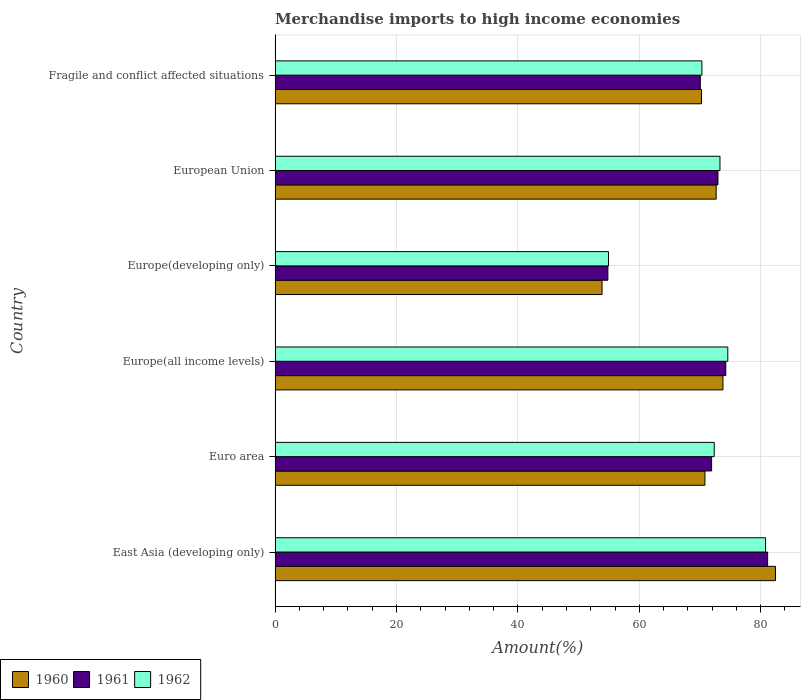Are the number of bars per tick equal to the number of legend labels?
Offer a terse response. Yes. Are the number of bars on each tick of the Y-axis equal?
Provide a succinct answer. Yes. How many bars are there on the 4th tick from the top?
Give a very brief answer. 3. How many bars are there on the 3rd tick from the bottom?
Ensure brevity in your answer.  3. What is the label of the 4th group of bars from the top?
Provide a succinct answer. Europe(all income levels). What is the percentage of amount earned from merchandise imports in 1960 in Fragile and conflict affected situations?
Your answer should be very brief. 70.25. Across all countries, what is the maximum percentage of amount earned from merchandise imports in 1962?
Provide a succinct answer. 80.8. Across all countries, what is the minimum percentage of amount earned from merchandise imports in 1962?
Make the answer very short. 54.93. In which country was the percentage of amount earned from merchandise imports in 1962 maximum?
Your response must be concise. East Asia (developing only). In which country was the percentage of amount earned from merchandise imports in 1962 minimum?
Your answer should be very brief. Europe(developing only). What is the total percentage of amount earned from merchandise imports in 1961 in the graph?
Your answer should be compact. 425.14. What is the difference between the percentage of amount earned from merchandise imports in 1961 in European Union and that in Fragile and conflict affected situations?
Offer a very short reply. 2.91. What is the difference between the percentage of amount earned from merchandise imports in 1960 in European Union and the percentage of amount earned from merchandise imports in 1962 in Fragile and conflict affected situations?
Your answer should be very brief. 2.35. What is the average percentage of amount earned from merchandise imports in 1961 per country?
Provide a succinct answer. 70.86. What is the difference between the percentage of amount earned from merchandise imports in 1960 and percentage of amount earned from merchandise imports in 1961 in Euro area?
Keep it short and to the point. -1.1. What is the ratio of the percentage of amount earned from merchandise imports in 1962 in East Asia (developing only) to that in Europe(developing only)?
Ensure brevity in your answer.  1.47. Is the difference between the percentage of amount earned from merchandise imports in 1960 in East Asia (developing only) and Europe(developing only) greater than the difference between the percentage of amount earned from merchandise imports in 1961 in East Asia (developing only) and Europe(developing only)?
Ensure brevity in your answer.  Yes. What is the difference between the highest and the second highest percentage of amount earned from merchandise imports in 1961?
Your answer should be very brief. 6.89. What is the difference between the highest and the lowest percentage of amount earned from merchandise imports in 1962?
Give a very brief answer. 25.88. In how many countries, is the percentage of amount earned from merchandise imports in 1960 greater than the average percentage of amount earned from merchandise imports in 1960 taken over all countries?
Provide a short and direct response. 4. What does the 2nd bar from the top in East Asia (developing only) represents?
Offer a very short reply. 1961. Is it the case that in every country, the sum of the percentage of amount earned from merchandise imports in 1961 and percentage of amount earned from merchandise imports in 1960 is greater than the percentage of amount earned from merchandise imports in 1962?
Make the answer very short. Yes. How many bars are there?
Ensure brevity in your answer.  18. Are all the bars in the graph horizontal?
Ensure brevity in your answer.  Yes. How many countries are there in the graph?
Your answer should be very brief. 6. What is the difference between two consecutive major ticks on the X-axis?
Your answer should be compact. 20. Does the graph contain any zero values?
Keep it short and to the point. No. Does the graph contain grids?
Your response must be concise. Yes. What is the title of the graph?
Give a very brief answer. Merchandise imports to high income economies. What is the label or title of the X-axis?
Your answer should be very brief. Amount(%). What is the label or title of the Y-axis?
Give a very brief answer. Country. What is the Amount(%) of 1960 in East Asia (developing only)?
Provide a succinct answer. 82.44. What is the Amount(%) in 1961 in East Asia (developing only)?
Make the answer very short. 81.14. What is the Amount(%) in 1962 in East Asia (developing only)?
Offer a terse response. 80.8. What is the Amount(%) of 1960 in Euro area?
Provide a short and direct response. 70.81. What is the Amount(%) of 1961 in Euro area?
Keep it short and to the point. 71.91. What is the Amount(%) in 1962 in Euro area?
Offer a very short reply. 72.34. What is the Amount(%) in 1960 in Europe(all income levels)?
Offer a terse response. 73.78. What is the Amount(%) of 1961 in Europe(all income levels)?
Give a very brief answer. 74.25. What is the Amount(%) in 1962 in Europe(all income levels)?
Provide a succinct answer. 74.58. What is the Amount(%) in 1960 in Europe(developing only)?
Ensure brevity in your answer.  53.86. What is the Amount(%) in 1961 in Europe(developing only)?
Ensure brevity in your answer.  54.82. What is the Amount(%) of 1962 in Europe(developing only)?
Provide a succinct answer. 54.93. What is the Amount(%) in 1960 in European Union?
Your response must be concise. 72.67. What is the Amount(%) in 1961 in European Union?
Your response must be concise. 72.96. What is the Amount(%) of 1962 in European Union?
Your answer should be compact. 73.29. What is the Amount(%) of 1960 in Fragile and conflict affected situations?
Offer a terse response. 70.25. What is the Amount(%) of 1961 in Fragile and conflict affected situations?
Your answer should be compact. 70.05. What is the Amount(%) in 1962 in Fragile and conflict affected situations?
Your answer should be very brief. 70.31. Across all countries, what is the maximum Amount(%) of 1960?
Provide a short and direct response. 82.44. Across all countries, what is the maximum Amount(%) of 1961?
Your response must be concise. 81.14. Across all countries, what is the maximum Amount(%) in 1962?
Your answer should be very brief. 80.8. Across all countries, what is the minimum Amount(%) of 1960?
Make the answer very short. 53.86. Across all countries, what is the minimum Amount(%) of 1961?
Offer a very short reply. 54.82. Across all countries, what is the minimum Amount(%) of 1962?
Your response must be concise. 54.93. What is the total Amount(%) of 1960 in the graph?
Offer a terse response. 423.81. What is the total Amount(%) of 1961 in the graph?
Ensure brevity in your answer.  425.14. What is the total Amount(%) of 1962 in the graph?
Make the answer very short. 426.25. What is the difference between the Amount(%) of 1960 in East Asia (developing only) and that in Euro area?
Give a very brief answer. 11.62. What is the difference between the Amount(%) of 1961 in East Asia (developing only) and that in Euro area?
Provide a short and direct response. 9.23. What is the difference between the Amount(%) in 1962 in East Asia (developing only) and that in Euro area?
Your answer should be very brief. 8.46. What is the difference between the Amount(%) of 1960 in East Asia (developing only) and that in Europe(all income levels)?
Offer a terse response. 8.65. What is the difference between the Amount(%) of 1961 in East Asia (developing only) and that in Europe(all income levels)?
Your answer should be compact. 6.89. What is the difference between the Amount(%) in 1962 in East Asia (developing only) and that in Europe(all income levels)?
Your answer should be very brief. 6.22. What is the difference between the Amount(%) in 1960 in East Asia (developing only) and that in Europe(developing only)?
Ensure brevity in your answer.  28.57. What is the difference between the Amount(%) of 1961 in East Asia (developing only) and that in Europe(developing only)?
Make the answer very short. 26.32. What is the difference between the Amount(%) in 1962 in East Asia (developing only) and that in Europe(developing only)?
Provide a succinct answer. 25.88. What is the difference between the Amount(%) of 1960 in East Asia (developing only) and that in European Union?
Make the answer very short. 9.77. What is the difference between the Amount(%) in 1961 in East Asia (developing only) and that in European Union?
Offer a very short reply. 8.18. What is the difference between the Amount(%) of 1962 in East Asia (developing only) and that in European Union?
Give a very brief answer. 7.51. What is the difference between the Amount(%) of 1960 in East Asia (developing only) and that in Fragile and conflict affected situations?
Offer a very short reply. 12.19. What is the difference between the Amount(%) in 1961 in East Asia (developing only) and that in Fragile and conflict affected situations?
Offer a terse response. 11.09. What is the difference between the Amount(%) in 1962 in East Asia (developing only) and that in Fragile and conflict affected situations?
Your answer should be compact. 10.49. What is the difference between the Amount(%) of 1960 in Euro area and that in Europe(all income levels)?
Your answer should be very brief. -2.97. What is the difference between the Amount(%) in 1961 in Euro area and that in Europe(all income levels)?
Make the answer very short. -2.33. What is the difference between the Amount(%) in 1962 in Euro area and that in Europe(all income levels)?
Give a very brief answer. -2.24. What is the difference between the Amount(%) in 1960 in Euro area and that in Europe(developing only)?
Your response must be concise. 16.95. What is the difference between the Amount(%) of 1961 in Euro area and that in Europe(developing only)?
Provide a succinct answer. 17.09. What is the difference between the Amount(%) in 1962 in Euro area and that in Europe(developing only)?
Give a very brief answer. 17.42. What is the difference between the Amount(%) of 1960 in Euro area and that in European Union?
Ensure brevity in your answer.  -1.85. What is the difference between the Amount(%) of 1961 in Euro area and that in European Union?
Your answer should be very brief. -1.05. What is the difference between the Amount(%) of 1962 in Euro area and that in European Union?
Your answer should be very brief. -0.95. What is the difference between the Amount(%) in 1960 in Euro area and that in Fragile and conflict affected situations?
Your answer should be compact. 0.56. What is the difference between the Amount(%) of 1961 in Euro area and that in Fragile and conflict affected situations?
Your answer should be very brief. 1.86. What is the difference between the Amount(%) in 1962 in Euro area and that in Fragile and conflict affected situations?
Your answer should be very brief. 2.03. What is the difference between the Amount(%) in 1960 in Europe(all income levels) and that in Europe(developing only)?
Provide a short and direct response. 19.92. What is the difference between the Amount(%) of 1961 in Europe(all income levels) and that in Europe(developing only)?
Provide a succinct answer. 19.42. What is the difference between the Amount(%) of 1962 in Europe(all income levels) and that in Europe(developing only)?
Offer a very short reply. 19.66. What is the difference between the Amount(%) of 1960 in Europe(all income levels) and that in European Union?
Ensure brevity in your answer.  1.12. What is the difference between the Amount(%) in 1961 in Europe(all income levels) and that in European Union?
Give a very brief answer. 1.29. What is the difference between the Amount(%) in 1962 in Europe(all income levels) and that in European Union?
Provide a short and direct response. 1.29. What is the difference between the Amount(%) of 1960 in Europe(all income levels) and that in Fragile and conflict affected situations?
Your answer should be compact. 3.53. What is the difference between the Amount(%) of 1961 in Europe(all income levels) and that in Fragile and conflict affected situations?
Offer a terse response. 4.2. What is the difference between the Amount(%) of 1962 in Europe(all income levels) and that in Fragile and conflict affected situations?
Provide a succinct answer. 4.27. What is the difference between the Amount(%) in 1960 in Europe(developing only) and that in European Union?
Give a very brief answer. -18.8. What is the difference between the Amount(%) in 1961 in Europe(developing only) and that in European Union?
Make the answer very short. -18.14. What is the difference between the Amount(%) of 1962 in Europe(developing only) and that in European Union?
Give a very brief answer. -18.37. What is the difference between the Amount(%) of 1960 in Europe(developing only) and that in Fragile and conflict affected situations?
Provide a short and direct response. -16.39. What is the difference between the Amount(%) in 1961 in Europe(developing only) and that in Fragile and conflict affected situations?
Offer a terse response. -15.23. What is the difference between the Amount(%) of 1962 in Europe(developing only) and that in Fragile and conflict affected situations?
Provide a short and direct response. -15.39. What is the difference between the Amount(%) of 1960 in European Union and that in Fragile and conflict affected situations?
Offer a terse response. 2.42. What is the difference between the Amount(%) in 1961 in European Union and that in Fragile and conflict affected situations?
Provide a succinct answer. 2.91. What is the difference between the Amount(%) of 1962 in European Union and that in Fragile and conflict affected situations?
Give a very brief answer. 2.98. What is the difference between the Amount(%) in 1960 in East Asia (developing only) and the Amount(%) in 1961 in Euro area?
Provide a short and direct response. 10.52. What is the difference between the Amount(%) of 1960 in East Asia (developing only) and the Amount(%) of 1962 in Euro area?
Give a very brief answer. 10.09. What is the difference between the Amount(%) of 1961 in East Asia (developing only) and the Amount(%) of 1962 in Euro area?
Offer a terse response. 8.8. What is the difference between the Amount(%) of 1960 in East Asia (developing only) and the Amount(%) of 1961 in Europe(all income levels)?
Keep it short and to the point. 8.19. What is the difference between the Amount(%) of 1960 in East Asia (developing only) and the Amount(%) of 1962 in Europe(all income levels)?
Your answer should be very brief. 7.85. What is the difference between the Amount(%) of 1961 in East Asia (developing only) and the Amount(%) of 1962 in Europe(all income levels)?
Offer a very short reply. 6.56. What is the difference between the Amount(%) of 1960 in East Asia (developing only) and the Amount(%) of 1961 in Europe(developing only)?
Your answer should be very brief. 27.61. What is the difference between the Amount(%) in 1960 in East Asia (developing only) and the Amount(%) in 1962 in Europe(developing only)?
Your answer should be very brief. 27.51. What is the difference between the Amount(%) in 1961 in East Asia (developing only) and the Amount(%) in 1962 in Europe(developing only)?
Ensure brevity in your answer.  26.22. What is the difference between the Amount(%) in 1960 in East Asia (developing only) and the Amount(%) in 1961 in European Union?
Provide a short and direct response. 9.48. What is the difference between the Amount(%) of 1960 in East Asia (developing only) and the Amount(%) of 1962 in European Union?
Provide a short and direct response. 9.14. What is the difference between the Amount(%) of 1961 in East Asia (developing only) and the Amount(%) of 1962 in European Union?
Provide a short and direct response. 7.85. What is the difference between the Amount(%) of 1960 in East Asia (developing only) and the Amount(%) of 1961 in Fragile and conflict affected situations?
Offer a terse response. 12.38. What is the difference between the Amount(%) in 1960 in East Asia (developing only) and the Amount(%) in 1962 in Fragile and conflict affected situations?
Your answer should be compact. 12.12. What is the difference between the Amount(%) in 1961 in East Asia (developing only) and the Amount(%) in 1962 in Fragile and conflict affected situations?
Ensure brevity in your answer.  10.83. What is the difference between the Amount(%) in 1960 in Euro area and the Amount(%) in 1961 in Europe(all income levels)?
Keep it short and to the point. -3.43. What is the difference between the Amount(%) of 1960 in Euro area and the Amount(%) of 1962 in Europe(all income levels)?
Make the answer very short. -3.77. What is the difference between the Amount(%) of 1961 in Euro area and the Amount(%) of 1962 in Europe(all income levels)?
Your response must be concise. -2.67. What is the difference between the Amount(%) of 1960 in Euro area and the Amount(%) of 1961 in Europe(developing only)?
Your response must be concise. 15.99. What is the difference between the Amount(%) in 1960 in Euro area and the Amount(%) in 1962 in Europe(developing only)?
Give a very brief answer. 15.89. What is the difference between the Amount(%) in 1961 in Euro area and the Amount(%) in 1962 in Europe(developing only)?
Provide a succinct answer. 16.99. What is the difference between the Amount(%) in 1960 in Euro area and the Amount(%) in 1961 in European Union?
Provide a succinct answer. -2.14. What is the difference between the Amount(%) in 1960 in Euro area and the Amount(%) in 1962 in European Union?
Your answer should be compact. -2.48. What is the difference between the Amount(%) of 1961 in Euro area and the Amount(%) of 1962 in European Union?
Your answer should be very brief. -1.38. What is the difference between the Amount(%) in 1960 in Euro area and the Amount(%) in 1961 in Fragile and conflict affected situations?
Provide a succinct answer. 0.76. What is the difference between the Amount(%) of 1960 in Euro area and the Amount(%) of 1962 in Fragile and conflict affected situations?
Make the answer very short. 0.5. What is the difference between the Amount(%) in 1961 in Euro area and the Amount(%) in 1962 in Fragile and conflict affected situations?
Your response must be concise. 1.6. What is the difference between the Amount(%) in 1960 in Europe(all income levels) and the Amount(%) in 1961 in Europe(developing only)?
Your answer should be compact. 18.96. What is the difference between the Amount(%) in 1960 in Europe(all income levels) and the Amount(%) in 1962 in Europe(developing only)?
Ensure brevity in your answer.  18.86. What is the difference between the Amount(%) of 1961 in Europe(all income levels) and the Amount(%) of 1962 in Europe(developing only)?
Offer a terse response. 19.32. What is the difference between the Amount(%) of 1960 in Europe(all income levels) and the Amount(%) of 1961 in European Union?
Make the answer very short. 0.82. What is the difference between the Amount(%) of 1960 in Europe(all income levels) and the Amount(%) of 1962 in European Union?
Ensure brevity in your answer.  0.49. What is the difference between the Amount(%) of 1961 in Europe(all income levels) and the Amount(%) of 1962 in European Union?
Offer a very short reply. 0.96. What is the difference between the Amount(%) in 1960 in Europe(all income levels) and the Amount(%) in 1961 in Fragile and conflict affected situations?
Your answer should be compact. 3.73. What is the difference between the Amount(%) of 1960 in Europe(all income levels) and the Amount(%) of 1962 in Fragile and conflict affected situations?
Ensure brevity in your answer.  3.47. What is the difference between the Amount(%) in 1961 in Europe(all income levels) and the Amount(%) in 1962 in Fragile and conflict affected situations?
Give a very brief answer. 3.94. What is the difference between the Amount(%) in 1960 in Europe(developing only) and the Amount(%) in 1961 in European Union?
Ensure brevity in your answer.  -19.09. What is the difference between the Amount(%) of 1960 in Europe(developing only) and the Amount(%) of 1962 in European Union?
Offer a very short reply. -19.43. What is the difference between the Amount(%) in 1961 in Europe(developing only) and the Amount(%) in 1962 in European Union?
Ensure brevity in your answer.  -18.47. What is the difference between the Amount(%) in 1960 in Europe(developing only) and the Amount(%) in 1961 in Fragile and conflict affected situations?
Ensure brevity in your answer.  -16.19. What is the difference between the Amount(%) in 1960 in Europe(developing only) and the Amount(%) in 1962 in Fragile and conflict affected situations?
Ensure brevity in your answer.  -16.45. What is the difference between the Amount(%) in 1961 in Europe(developing only) and the Amount(%) in 1962 in Fragile and conflict affected situations?
Offer a very short reply. -15.49. What is the difference between the Amount(%) in 1960 in European Union and the Amount(%) in 1961 in Fragile and conflict affected situations?
Ensure brevity in your answer.  2.61. What is the difference between the Amount(%) in 1960 in European Union and the Amount(%) in 1962 in Fragile and conflict affected situations?
Provide a succinct answer. 2.35. What is the difference between the Amount(%) in 1961 in European Union and the Amount(%) in 1962 in Fragile and conflict affected situations?
Keep it short and to the point. 2.65. What is the average Amount(%) of 1960 per country?
Ensure brevity in your answer.  70.64. What is the average Amount(%) of 1961 per country?
Make the answer very short. 70.86. What is the average Amount(%) in 1962 per country?
Make the answer very short. 71.04. What is the difference between the Amount(%) of 1960 and Amount(%) of 1961 in East Asia (developing only)?
Provide a succinct answer. 1.29. What is the difference between the Amount(%) in 1960 and Amount(%) in 1962 in East Asia (developing only)?
Provide a succinct answer. 1.63. What is the difference between the Amount(%) in 1961 and Amount(%) in 1962 in East Asia (developing only)?
Your answer should be compact. 0.34. What is the difference between the Amount(%) of 1960 and Amount(%) of 1961 in Euro area?
Make the answer very short. -1.1. What is the difference between the Amount(%) of 1960 and Amount(%) of 1962 in Euro area?
Offer a very short reply. -1.53. What is the difference between the Amount(%) in 1961 and Amount(%) in 1962 in Euro area?
Your answer should be compact. -0.43. What is the difference between the Amount(%) in 1960 and Amount(%) in 1961 in Europe(all income levels)?
Keep it short and to the point. -0.47. What is the difference between the Amount(%) in 1960 and Amount(%) in 1962 in Europe(all income levels)?
Keep it short and to the point. -0.8. What is the difference between the Amount(%) of 1961 and Amount(%) of 1962 in Europe(all income levels)?
Provide a short and direct response. -0.33. What is the difference between the Amount(%) in 1960 and Amount(%) in 1961 in Europe(developing only)?
Offer a terse response. -0.96. What is the difference between the Amount(%) in 1960 and Amount(%) in 1962 in Europe(developing only)?
Provide a succinct answer. -1.06. What is the difference between the Amount(%) of 1961 and Amount(%) of 1962 in Europe(developing only)?
Ensure brevity in your answer.  -0.1. What is the difference between the Amount(%) of 1960 and Amount(%) of 1961 in European Union?
Your answer should be very brief. -0.29. What is the difference between the Amount(%) in 1960 and Amount(%) in 1962 in European Union?
Provide a short and direct response. -0.63. What is the difference between the Amount(%) of 1961 and Amount(%) of 1962 in European Union?
Your answer should be very brief. -0.33. What is the difference between the Amount(%) of 1960 and Amount(%) of 1961 in Fragile and conflict affected situations?
Your response must be concise. 0.2. What is the difference between the Amount(%) in 1960 and Amount(%) in 1962 in Fragile and conflict affected situations?
Make the answer very short. -0.06. What is the difference between the Amount(%) of 1961 and Amount(%) of 1962 in Fragile and conflict affected situations?
Your answer should be compact. -0.26. What is the ratio of the Amount(%) in 1960 in East Asia (developing only) to that in Euro area?
Your response must be concise. 1.16. What is the ratio of the Amount(%) in 1961 in East Asia (developing only) to that in Euro area?
Provide a short and direct response. 1.13. What is the ratio of the Amount(%) in 1962 in East Asia (developing only) to that in Euro area?
Make the answer very short. 1.12. What is the ratio of the Amount(%) of 1960 in East Asia (developing only) to that in Europe(all income levels)?
Keep it short and to the point. 1.12. What is the ratio of the Amount(%) in 1961 in East Asia (developing only) to that in Europe(all income levels)?
Offer a terse response. 1.09. What is the ratio of the Amount(%) in 1962 in East Asia (developing only) to that in Europe(all income levels)?
Keep it short and to the point. 1.08. What is the ratio of the Amount(%) of 1960 in East Asia (developing only) to that in Europe(developing only)?
Offer a terse response. 1.53. What is the ratio of the Amount(%) in 1961 in East Asia (developing only) to that in Europe(developing only)?
Provide a succinct answer. 1.48. What is the ratio of the Amount(%) in 1962 in East Asia (developing only) to that in Europe(developing only)?
Provide a succinct answer. 1.47. What is the ratio of the Amount(%) of 1960 in East Asia (developing only) to that in European Union?
Your response must be concise. 1.13. What is the ratio of the Amount(%) of 1961 in East Asia (developing only) to that in European Union?
Keep it short and to the point. 1.11. What is the ratio of the Amount(%) in 1962 in East Asia (developing only) to that in European Union?
Your answer should be compact. 1.1. What is the ratio of the Amount(%) of 1960 in East Asia (developing only) to that in Fragile and conflict affected situations?
Make the answer very short. 1.17. What is the ratio of the Amount(%) in 1961 in East Asia (developing only) to that in Fragile and conflict affected situations?
Offer a very short reply. 1.16. What is the ratio of the Amount(%) in 1962 in East Asia (developing only) to that in Fragile and conflict affected situations?
Provide a succinct answer. 1.15. What is the ratio of the Amount(%) in 1960 in Euro area to that in Europe(all income levels)?
Offer a very short reply. 0.96. What is the ratio of the Amount(%) of 1961 in Euro area to that in Europe(all income levels)?
Your answer should be very brief. 0.97. What is the ratio of the Amount(%) of 1960 in Euro area to that in Europe(developing only)?
Make the answer very short. 1.31. What is the ratio of the Amount(%) in 1961 in Euro area to that in Europe(developing only)?
Make the answer very short. 1.31. What is the ratio of the Amount(%) of 1962 in Euro area to that in Europe(developing only)?
Make the answer very short. 1.32. What is the ratio of the Amount(%) in 1960 in Euro area to that in European Union?
Your answer should be compact. 0.97. What is the ratio of the Amount(%) in 1961 in Euro area to that in European Union?
Your response must be concise. 0.99. What is the ratio of the Amount(%) in 1962 in Euro area to that in European Union?
Make the answer very short. 0.99. What is the ratio of the Amount(%) of 1961 in Euro area to that in Fragile and conflict affected situations?
Offer a very short reply. 1.03. What is the ratio of the Amount(%) of 1962 in Euro area to that in Fragile and conflict affected situations?
Keep it short and to the point. 1.03. What is the ratio of the Amount(%) of 1960 in Europe(all income levels) to that in Europe(developing only)?
Give a very brief answer. 1.37. What is the ratio of the Amount(%) of 1961 in Europe(all income levels) to that in Europe(developing only)?
Give a very brief answer. 1.35. What is the ratio of the Amount(%) of 1962 in Europe(all income levels) to that in Europe(developing only)?
Ensure brevity in your answer.  1.36. What is the ratio of the Amount(%) in 1960 in Europe(all income levels) to that in European Union?
Provide a short and direct response. 1.02. What is the ratio of the Amount(%) in 1961 in Europe(all income levels) to that in European Union?
Give a very brief answer. 1.02. What is the ratio of the Amount(%) in 1962 in Europe(all income levels) to that in European Union?
Your answer should be very brief. 1.02. What is the ratio of the Amount(%) of 1960 in Europe(all income levels) to that in Fragile and conflict affected situations?
Provide a short and direct response. 1.05. What is the ratio of the Amount(%) of 1961 in Europe(all income levels) to that in Fragile and conflict affected situations?
Provide a short and direct response. 1.06. What is the ratio of the Amount(%) of 1962 in Europe(all income levels) to that in Fragile and conflict affected situations?
Your response must be concise. 1.06. What is the ratio of the Amount(%) of 1960 in Europe(developing only) to that in European Union?
Give a very brief answer. 0.74. What is the ratio of the Amount(%) in 1961 in Europe(developing only) to that in European Union?
Provide a short and direct response. 0.75. What is the ratio of the Amount(%) of 1962 in Europe(developing only) to that in European Union?
Provide a succinct answer. 0.75. What is the ratio of the Amount(%) in 1960 in Europe(developing only) to that in Fragile and conflict affected situations?
Keep it short and to the point. 0.77. What is the ratio of the Amount(%) of 1961 in Europe(developing only) to that in Fragile and conflict affected situations?
Keep it short and to the point. 0.78. What is the ratio of the Amount(%) in 1962 in Europe(developing only) to that in Fragile and conflict affected situations?
Ensure brevity in your answer.  0.78. What is the ratio of the Amount(%) in 1960 in European Union to that in Fragile and conflict affected situations?
Offer a terse response. 1.03. What is the ratio of the Amount(%) in 1961 in European Union to that in Fragile and conflict affected situations?
Give a very brief answer. 1.04. What is the ratio of the Amount(%) in 1962 in European Union to that in Fragile and conflict affected situations?
Give a very brief answer. 1.04. What is the difference between the highest and the second highest Amount(%) in 1960?
Offer a very short reply. 8.65. What is the difference between the highest and the second highest Amount(%) in 1961?
Keep it short and to the point. 6.89. What is the difference between the highest and the second highest Amount(%) in 1962?
Make the answer very short. 6.22. What is the difference between the highest and the lowest Amount(%) in 1960?
Provide a succinct answer. 28.57. What is the difference between the highest and the lowest Amount(%) of 1961?
Keep it short and to the point. 26.32. What is the difference between the highest and the lowest Amount(%) of 1962?
Offer a very short reply. 25.88. 